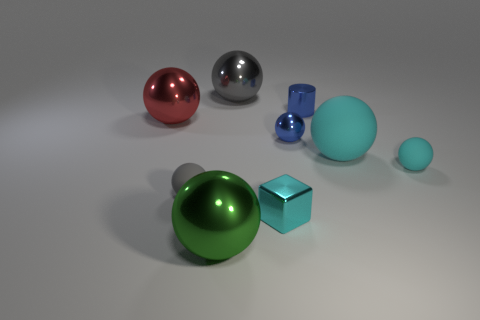Subtract 2 balls. How many balls are left? 5 Subtract all red spheres. How many spheres are left? 6 Subtract all tiny gray balls. How many balls are left? 6 Subtract all yellow spheres. Subtract all cyan cubes. How many spheres are left? 7 Add 1 gray spheres. How many objects exist? 10 Subtract all blocks. How many objects are left? 8 Subtract all red things. Subtract all blue shiny balls. How many objects are left? 7 Add 3 tiny metal cubes. How many tiny metal cubes are left? 4 Add 3 big cyan matte spheres. How many big cyan matte spheres exist? 4 Subtract 0 yellow cylinders. How many objects are left? 9 